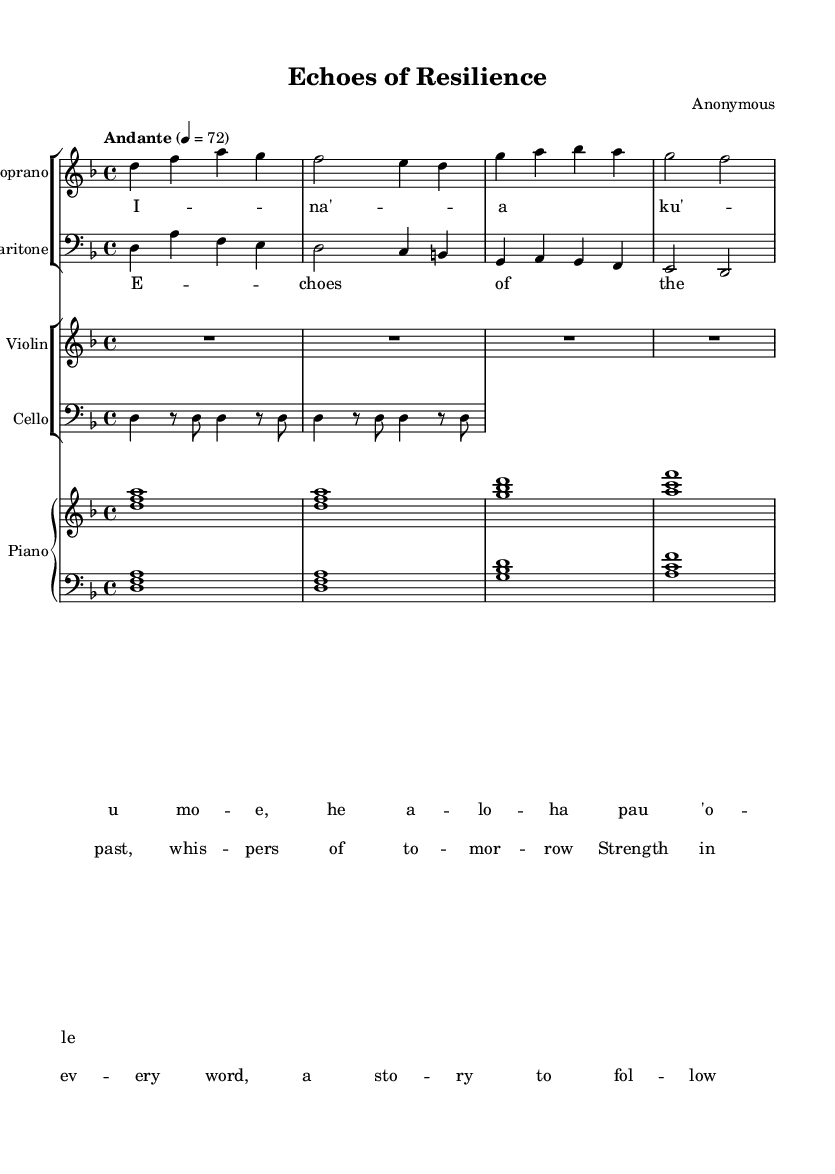What is the key signature of this music? The key signature is indicated by the sharp or flat symbols at the beginning of the staff. In this case, there are no sharps or flats indicated, which means the piece is in D minor, as established in the global section of the code.
Answer: D minor What is the time signature of this music? The time signature appears at the beginning of the music, indicating how many beats are in each measure. Here, it is shown as 4/4, meaning four beats per measure and a quarter note gets one beat.
Answer: 4/4 What is the tempo marking for this piece? The tempo marking is found at the beginning of the piece, right after the time signature. The term "Andante" indicates a moderate tempo, and the number "4 = 72" specifies that there are 72 beats per minute.
Answer: Andante How many voices are present in this opera piece? The music sheet includes a soprano and baritone part, which indicates there are two vocal voices present. Each voice has its own staff for scoring.
Answer: Two voices Which instrument is not playing during the first measure? The violin has a rest symbol represented by "R1*4" in the first measure, indicating that it does not play during this time, while other instruments do.
Answer: Violin What is the main theme expressed in the chorus? The chorus lyrics describe themes of the past and strength, indicating resilience and hope. Analyzing the text reveals a focus on stories of survival.
Answer: Resilience How many measures are there in the cello part before the first note is played? The cello part includes a sequence that begins with rest, showing that it remains silent for the first two measures before playing the note D.
Answer: Two measures 